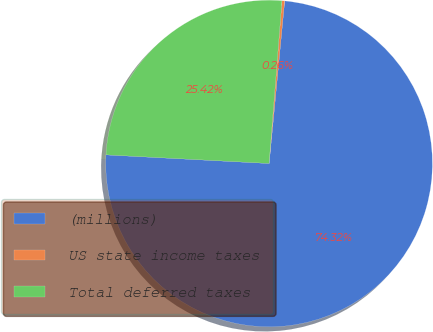Convert chart. <chart><loc_0><loc_0><loc_500><loc_500><pie_chart><fcel>(millions)<fcel>US state income taxes<fcel>Total deferred taxes<nl><fcel>74.33%<fcel>0.26%<fcel>25.42%<nl></chart> 